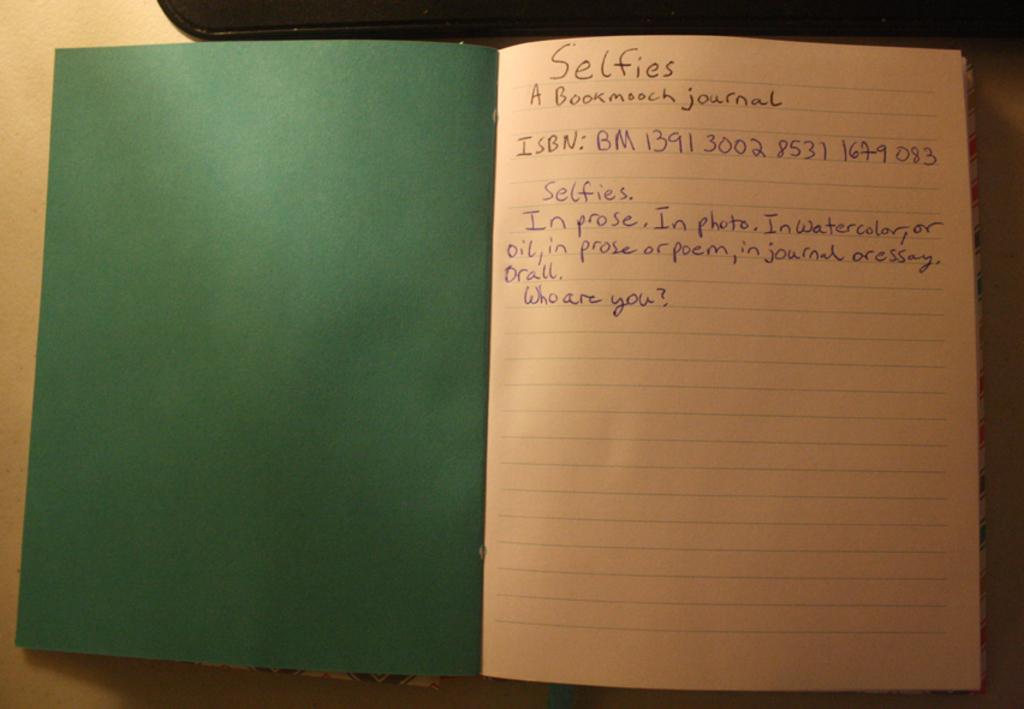What is the main subject of the journal entry?
Ensure brevity in your answer.  Selfies. What is the isbn for this entry?
Offer a terse response. Bm 1391 3002 8531 1679 083. 